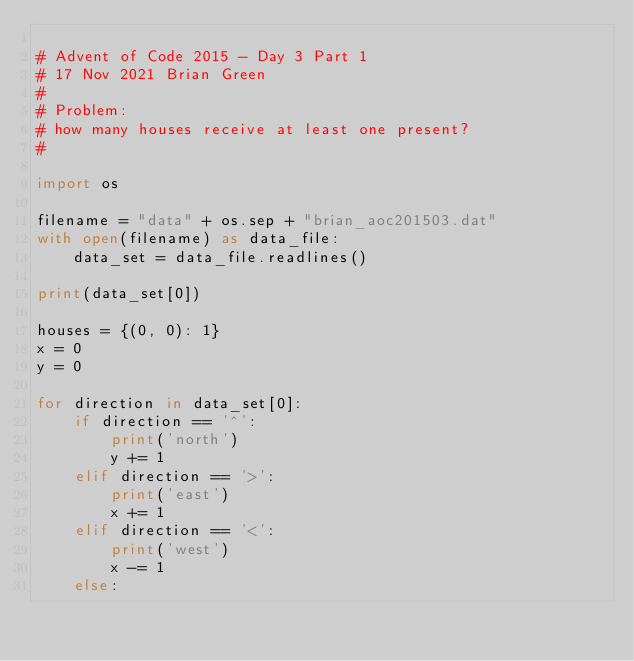<code> <loc_0><loc_0><loc_500><loc_500><_Python_>
# Advent of Code 2015 - Day 3 Part 1
# 17 Nov 2021 Brian Green
#
# Problem:
# how many houses receive at least one present?
#

import os

filename = "data" + os.sep + "brian_aoc201503.dat"
with open(filename) as data_file:
    data_set = data_file.readlines()

print(data_set[0])

houses = {(0, 0): 1}
x = 0
y = 0

for direction in data_set[0]:
    if direction == '^':
        print('north')
        y += 1
    elif direction == '>':
        print('east')
        x += 1
    elif direction == '<':
        print('west')
        x -= 1
    else:</code> 